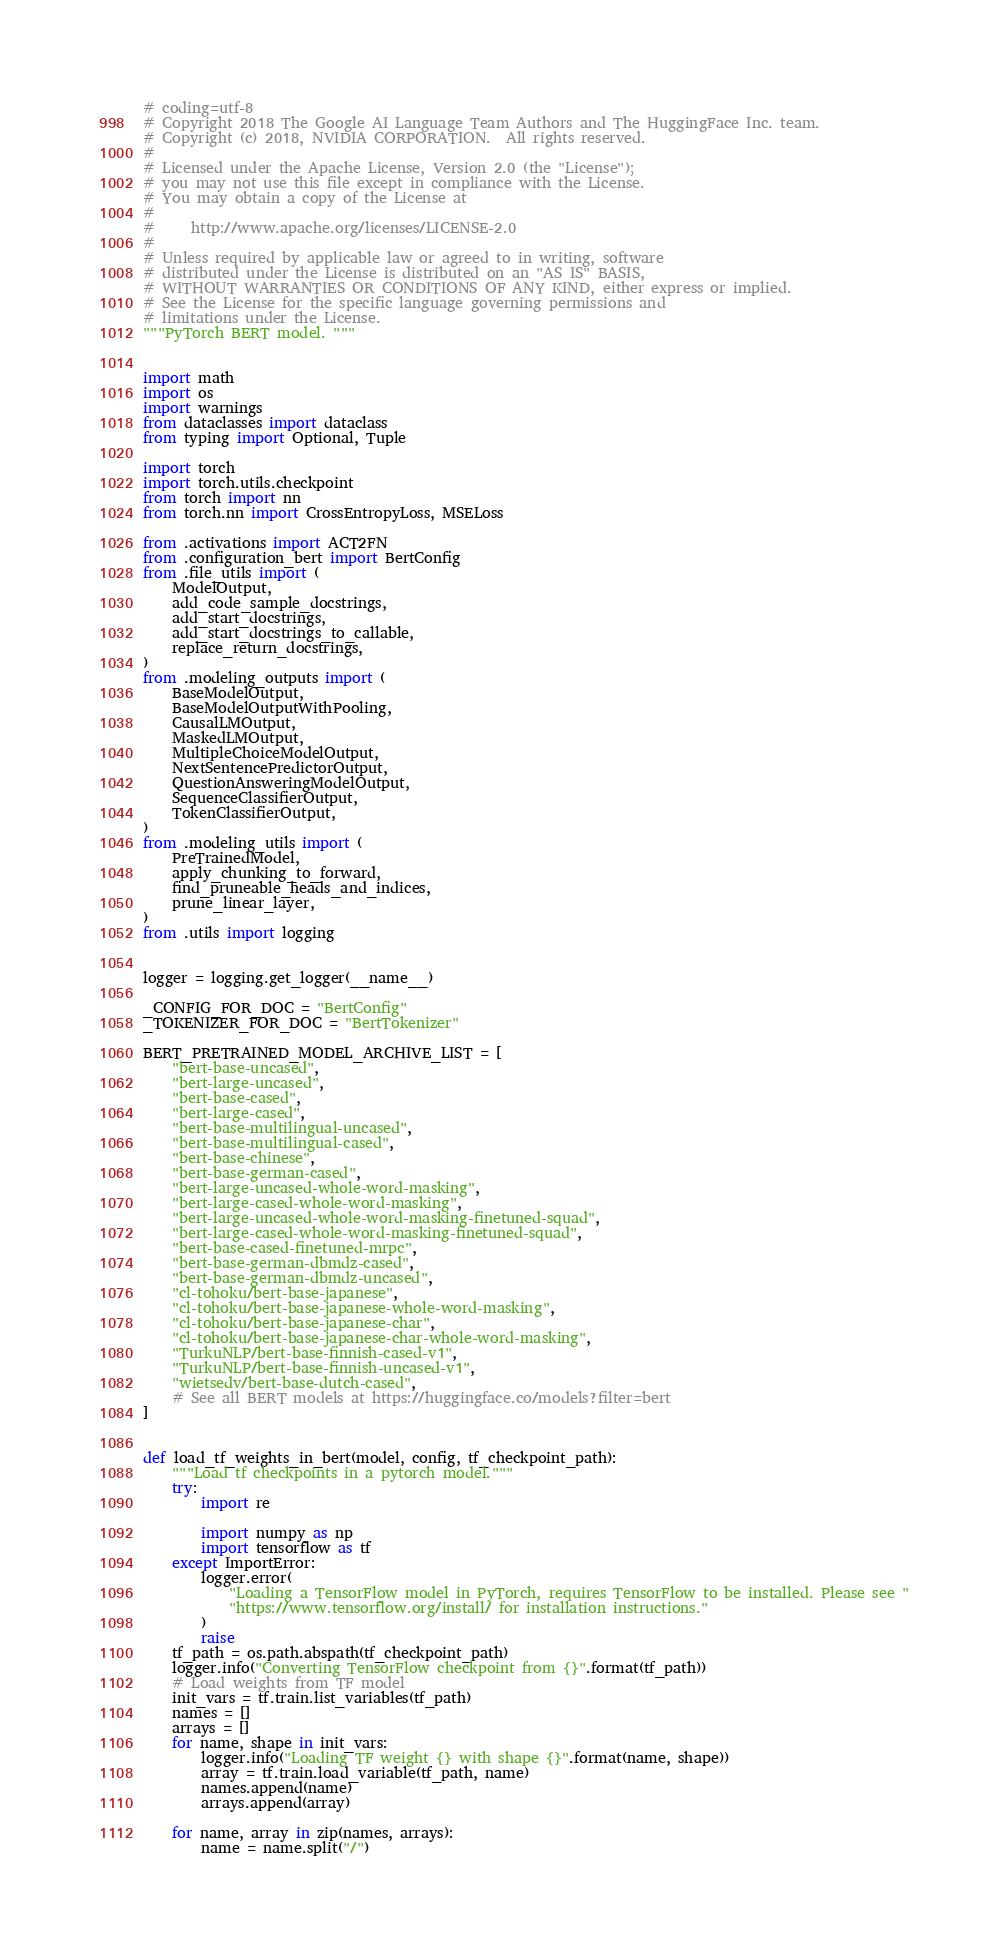<code> <loc_0><loc_0><loc_500><loc_500><_Python_># coding=utf-8
# Copyright 2018 The Google AI Language Team Authors and The HuggingFace Inc. team.
# Copyright (c) 2018, NVIDIA CORPORATION.  All rights reserved.
#
# Licensed under the Apache License, Version 2.0 (the "License");
# you may not use this file except in compliance with the License.
# You may obtain a copy of the License at
#
#     http://www.apache.org/licenses/LICENSE-2.0
#
# Unless required by applicable law or agreed to in writing, software
# distributed under the License is distributed on an "AS IS" BASIS,
# WITHOUT WARRANTIES OR CONDITIONS OF ANY KIND, either express or implied.
# See the License for the specific language governing permissions and
# limitations under the License.
"""PyTorch BERT model. """


import math
import os
import warnings
from dataclasses import dataclass
from typing import Optional, Tuple

import torch
import torch.utils.checkpoint
from torch import nn
from torch.nn import CrossEntropyLoss, MSELoss

from .activations import ACT2FN
from .configuration_bert import BertConfig
from .file_utils import (
    ModelOutput,
    add_code_sample_docstrings,
    add_start_docstrings,
    add_start_docstrings_to_callable,
    replace_return_docstrings,
)
from .modeling_outputs import (
    BaseModelOutput,
    BaseModelOutputWithPooling,
    CausalLMOutput,
    MaskedLMOutput,
    MultipleChoiceModelOutput,
    NextSentencePredictorOutput,
    QuestionAnsweringModelOutput,
    SequenceClassifierOutput,
    TokenClassifierOutput,
)
from .modeling_utils import (
    PreTrainedModel,
    apply_chunking_to_forward,
    find_pruneable_heads_and_indices,
    prune_linear_layer,
)
from .utils import logging


logger = logging.get_logger(__name__)

_CONFIG_FOR_DOC = "BertConfig"
_TOKENIZER_FOR_DOC = "BertTokenizer"

BERT_PRETRAINED_MODEL_ARCHIVE_LIST = [
    "bert-base-uncased",
    "bert-large-uncased",
    "bert-base-cased",
    "bert-large-cased",
    "bert-base-multilingual-uncased",
    "bert-base-multilingual-cased",
    "bert-base-chinese",
    "bert-base-german-cased",
    "bert-large-uncased-whole-word-masking",
    "bert-large-cased-whole-word-masking",
    "bert-large-uncased-whole-word-masking-finetuned-squad",
    "bert-large-cased-whole-word-masking-finetuned-squad",
    "bert-base-cased-finetuned-mrpc",
    "bert-base-german-dbmdz-cased",
    "bert-base-german-dbmdz-uncased",
    "cl-tohoku/bert-base-japanese",
    "cl-tohoku/bert-base-japanese-whole-word-masking",
    "cl-tohoku/bert-base-japanese-char",
    "cl-tohoku/bert-base-japanese-char-whole-word-masking",
    "TurkuNLP/bert-base-finnish-cased-v1",
    "TurkuNLP/bert-base-finnish-uncased-v1",
    "wietsedv/bert-base-dutch-cased",
    # See all BERT models at https://huggingface.co/models?filter=bert
]


def load_tf_weights_in_bert(model, config, tf_checkpoint_path):
    """Load tf checkpoints in a pytorch model."""
    try:
        import re

        import numpy as np
        import tensorflow as tf
    except ImportError:
        logger.error(
            "Loading a TensorFlow model in PyTorch, requires TensorFlow to be installed. Please see "
            "https://www.tensorflow.org/install/ for installation instructions."
        )
        raise
    tf_path = os.path.abspath(tf_checkpoint_path)
    logger.info("Converting TensorFlow checkpoint from {}".format(tf_path))
    # Load weights from TF model
    init_vars = tf.train.list_variables(tf_path)
    names = []
    arrays = []
    for name, shape in init_vars:
        logger.info("Loading TF weight {} with shape {}".format(name, shape))
        array = tf.train.load_variable(tf_path, name)
        names.append(name)
        arrays.append(array)

    for name, array in zip(names, arrays):
        name = name.split("/")</code> 